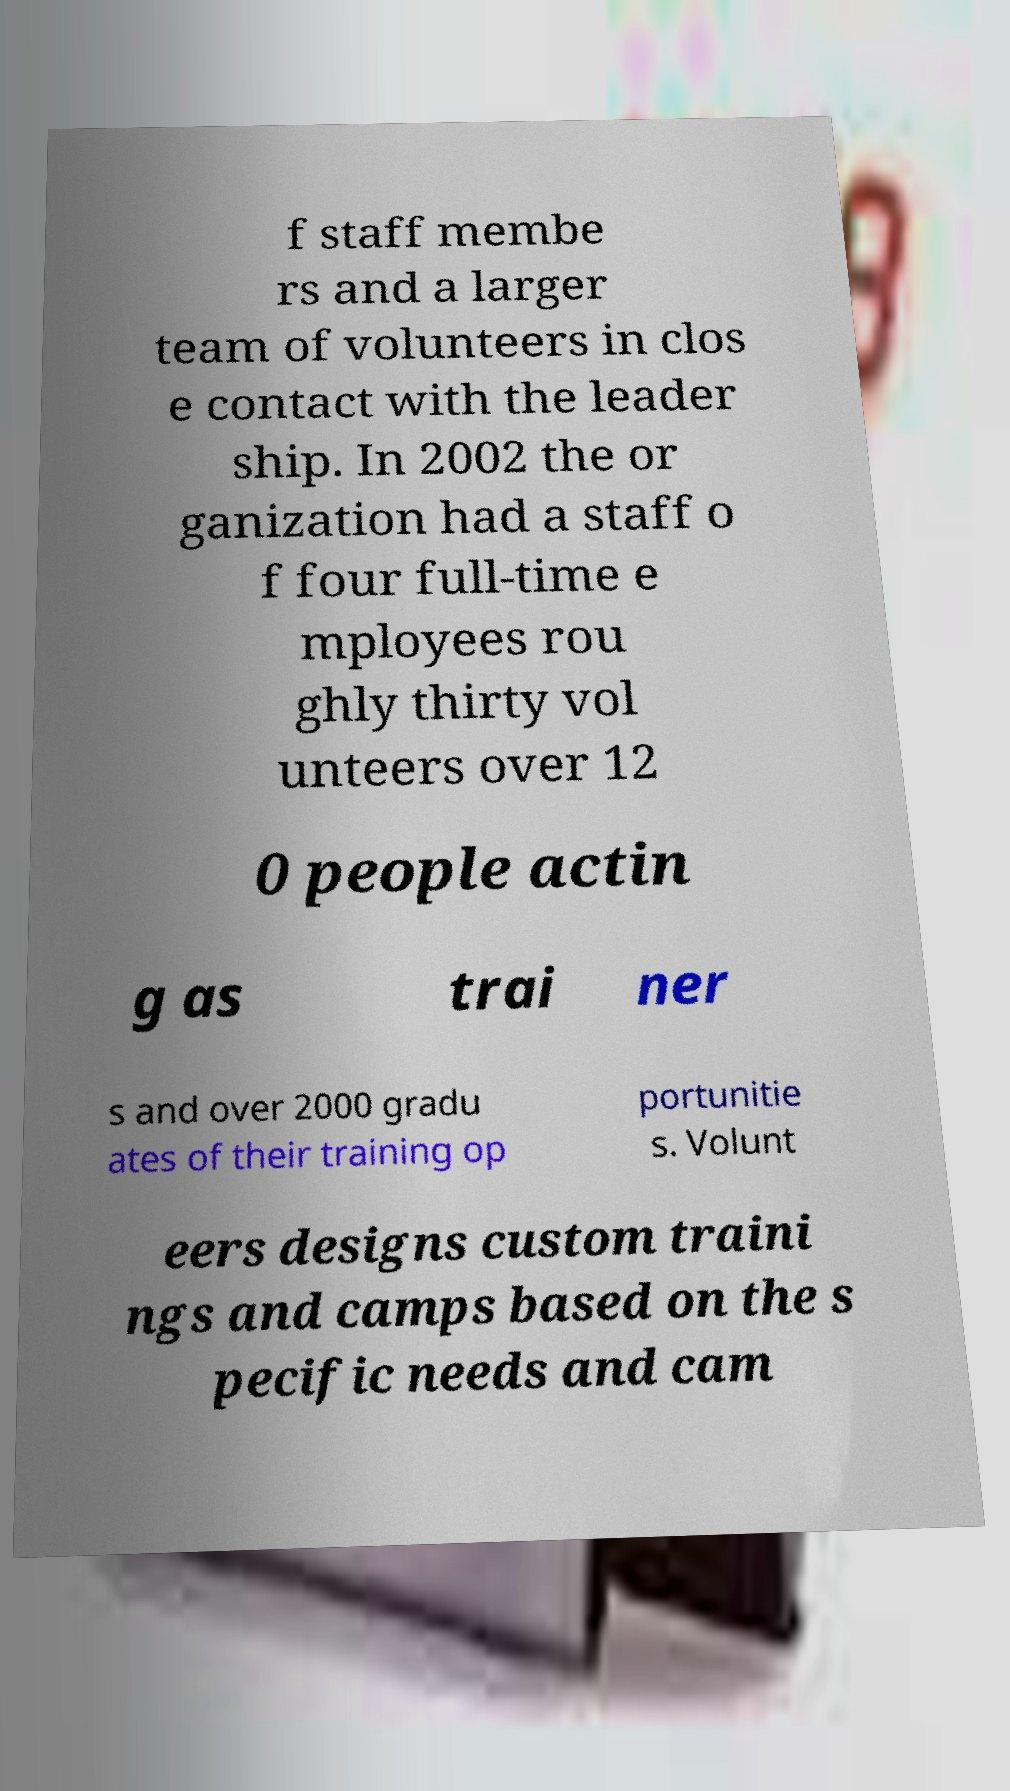There's text embedded in this image that I need extracted. Can you transcribe it verbatim? f staff membe rs and a larger team of volunteers in clos e contact with the leader ship. In 2002 the or ganization had a staff o f four full-time e mployees rou ghly thirty vol unteers over 12 0 people actin g as trai ner s and over 2000 gradu ates of their training op portunitie s. Volunt eers designs custom traini ngs and camps based on the s pecific needs and cam 